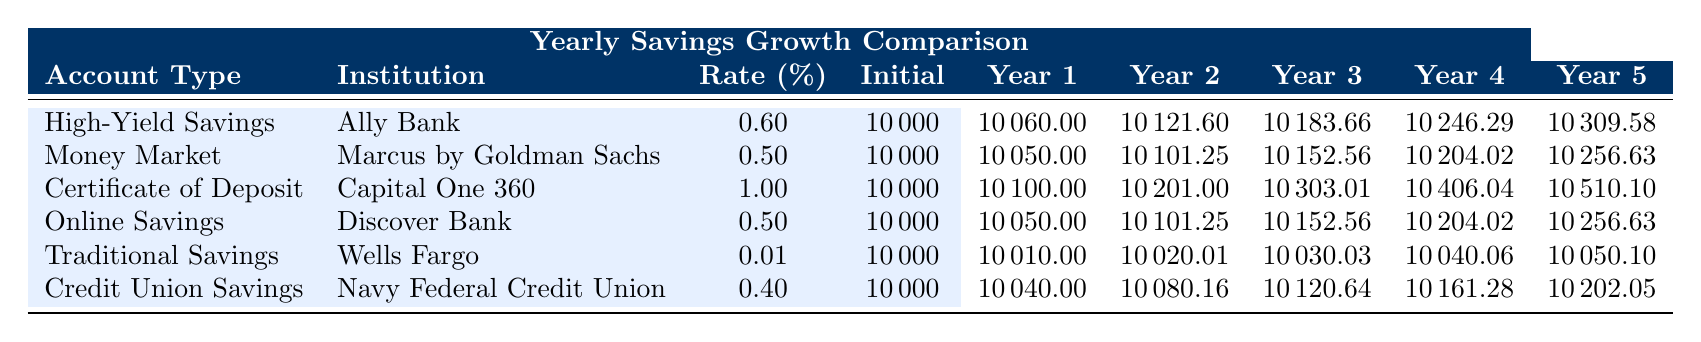What is the highest interest rate among the accounts listed? By looking at the 'Rate (%)' column, the highest interest rate is listed for the Certificate of Deposit at 1.00%.
Answer: 1.00% Which account has the largest amount after Year 5? The amounts for Year 5 are 10309.58, 10256.63, 10510.10, 10256.63, 10050.10, and 10202.05. The largest is 10510.10 from the Certificate of Deposit.
Answer: 10510.10 If I deposit $10,000 in the High-Yield Savings Account, how much will I have after 3 years? The amount after 3 years for the High-Yield Savings Account is listed as 10183.66.
Answer: 10183.66 What is the difference in the final amounts between the Certificate of Deposit and the Traditional Savings Account after Year 5? The final amounts are 10510.10 (CD) and 10050.10 (Traditional). The difference is calculated as 10510.10 - 10050.10 = 460.00.
Answer: 460.00 Which account would yield the most savings after 2 years, High-Yield Savings or Money Market Account? The High-Yield Savings Account has 10121.60 after 2 years, while the Money Market Account has 10101.25. The High-Yield Savings Account yields more.
Answer: High-Yield Savings Account Is the interest rate for the Credit Union Savings Account higher than the Traditional Savings Account? The interest rate for Credit Union Savings is 0.40%, while Traditional Savings is 0.01%. Hence, the Credit Union Savings Account has a higher interest rate.
Answer: Yes What is the average amount after Year 1 across all accounts? The amounts after Year 1 are: 10060.00, 10050.00, 10100.00, 10050.00, 10010.00, and 10040.00. Summing these gives 60310.00, and dividing by 6 gives an average of 10051.67.
Answer: 10051.67 If I want to compare only the Online Savings Account and the Certificate of Deposit, which one provides more savings after Year 4? The amounts after Year 4 are 10204.02 for Online Savings and 10406.04 for Certificate of Deposit. The Certificate of Deposit provides more savings.
Answer: Certificate of Deposit Which account type will result in the least growth after 5 years? After analyzing the final amounts, the Traditional Savings Account shows the least amount with 10050.10 after 5 years.
Answer: Traditional Savings Account Does a Money Market Account grow at a faster rate than a High-Yield Savings Account after 1 year? After Year 1, the Money Market Account grows to 10050.00 compared to the High-Yield Savings Account's 10060.00. Thus, it does not grow faster.
Answer: No 